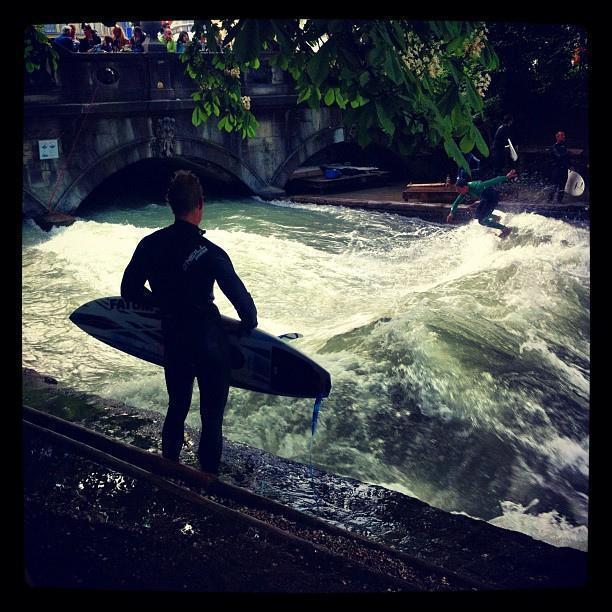How many adult birds are there?
Give a very brief answer. 0. 